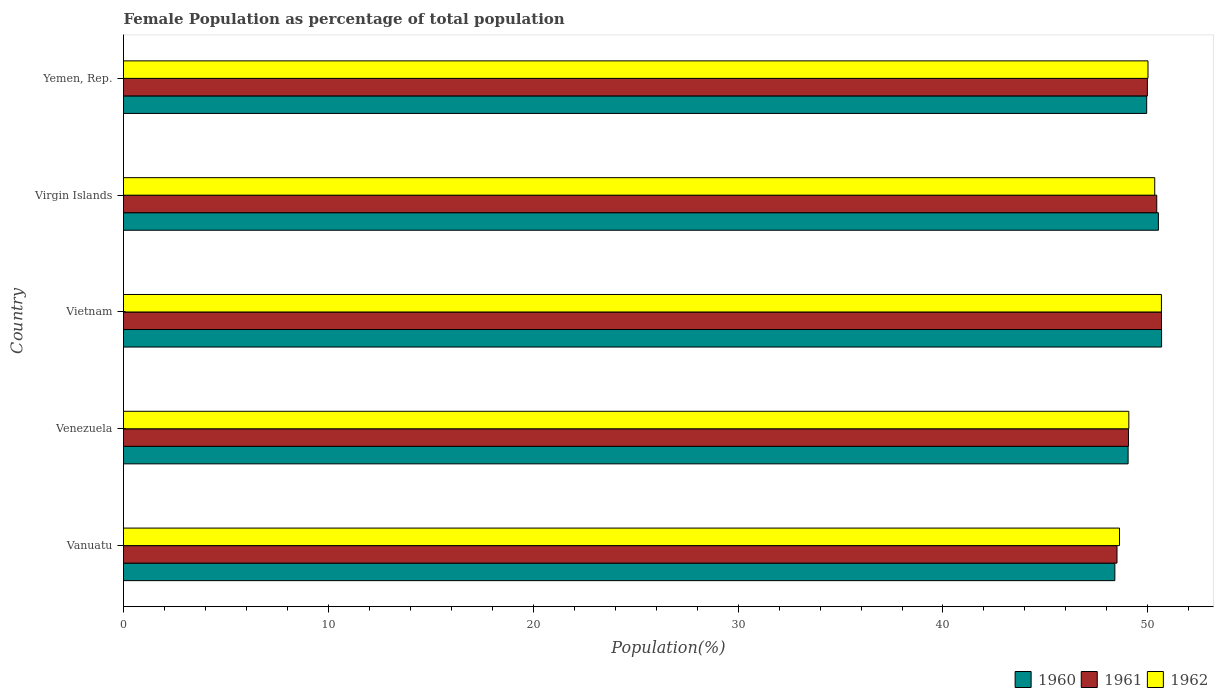Are the number of bars per tick equal to the number of legend labels?
Your response must be concise. Yes. Are the number of bars on each tick of the Y-axis equal?
Your answer should be very brief. Yes. How many bars are there on the 5th tick from the top?
Provide a succinct answer. 3. What is the label of the 2nd group of bars from the top?
Make the answer very short. Virgin Islands. What is the female population in in 1962 in Virgin Islands?
Your answer should be very brief. 50.34. Across all countries, what is the maximum female population in in 1961?
Your response must be concise. 50.67. Across all countries, what is the minimum female population in in 1962?
Your response must be concise. 48.62. In which country was the female population in in 1961 maximum?
Your answer should be compact. Vietnam. In which country was the female population in in 1960 minimum?
Provide a succinct answer. Vanuatu. What is the total female population in in 1962 in the graph?
Provide a short and direct response. 248.69. What is the difference between the female population in in 1960 in Vanuatu and that in Virgin Islands?
Provide a short and direct response. -2.12. What is the difference between the female population in in 1962 in Venezuela and the female population in in 1961 in Vanuatu?
Offer a terse response. 0.58. What is the average female population in in 1961 per country?
Provide a short and direct response. 49.73. What is the difference between the female population in in 1961 and female population in in 1962 in Virgin Islands?
Keep it short and to the point. 0.1. In how many countries, is the female population in in 1960 greater than 24 %?
Make the answer very short. 5. What is the ratio of the female population in in 1961 in Vanuatu to that in Vietnam?
Provide a short and direct response. 0.96. Is the difference between the female population in in 1961 in Vietnam and Yemen, Rep. greater than the difference between the female population in in 1962 in Vietnam and Yemen, Rep.?
Keep it short and to the point. Yes. What is the difference between the highest and the second highest female population in in 1960?
Your response must be concise. 0.16. What is the difference between the highest and the lowest female population in in 1960?
Your response must be concise. 2.28. What does the 3rd bar from the top in Yemen, Rep. represents?
Your answer should be compact. 1960. How many bars are there?
Your answer should be very brief. 15. How many countries are there in the graph?
Make the answer very short. 5. What is the difference between two consecutive major ticks on the X-axis?
Provide a short and direct response. 10. How are the legend labels stacked?
Make the answer very short. Horizontal. What is the title of the graph?
Your answer should be compact. Female Population as percentage of total population. Does "1964" appear as one of the legend labels in the graph?
Make the answer very short. No. What is the label or title of the X-axis?
Ensure brevity in your answer.  Population(%). What is the label or title of the Y-axis?
Make the answer very short. Country. What is the Population(%) in 1960 in Vanuatu?
Your answer should be very brief. 48.39. What is the Population(%) of 1961 in Vanuatu?
Keep it short and to the point. 48.49. What is the Population(%) in 1962 in Vanuatu?
Offer a very short reply. 48.62. What is the Population(%) in 1960 in Venezuela?
Offer a very short reply. 49.04. What is the Population(%) in 1961 in Venezuela?
Offer a very short reply. 49.05. What is the Population(%) in 1962 in Venezuela?
Give a very brief answer. 49.07. What is the Population(%) in 1960 in Vietnam?
Your response must be concise. 50.67. What is the Population(%) of 1961 in Vietnam?
Provide a short and direct response. 50.67. What is the Population(%) of 1962 in Vietnam?
Offer a terse response. 50.66. What is the Population(%) of 1960 in Virgin Islands?
Provide a succinct answer. 50.51. What is the Population(%) in 1961 in Virgin Islands?
Offer a terse response. 50.43. What is the Population(%) of 1962 in Virgin Islands?
Your answer should be very brief. 50.34. What is the Population(%) of 1960 in Yemen, Rep.?
Provide a succinct answer. 49.94. What is the Population(%) of 1961 in Yemen, Rep.?
Make the answer very short. 49.98. What is the Population(%) of 1962 in Yemen, Rep.?
Ensure brevity in your answer.  50.01. Across all countries, what is the maximum Population(%) of 1960?
Your response must be concise. 50.67. Across all countries, what is the maximum Population(%) of 1961?
Ensure brevity in your answer.  50.67. Across all countries, what is the maximum Population(%) in 1962?
Make the answer very short. 50.66. Across all countries, what is the minimum Population(%) of 1960?
Your answer should be very brief. 48.39. Across all countries, what is the minimum Population(%) in 1961?
Your response must be concise. 48.49. Across all countries, what is the minimum Population(%) in 1962?
Provide a succinct answer. 48.62. What is the total Population(%) of 1960 in the graph?
Keep it short and to the point. 248.56. What is the total Population(%) in 1961 in the graph?
Keep it short and to the point. 248.63. What is the total Population(%) in 1962 in the graph?
Provide a succinct answer. 248.69. What is the difference between the Population(%) of 1960 in Vanuatu and that in Venezuela?
Your response must be concise. -0.65. What is the difference between the Population(%) of 1961 in Vanuatu and that in Venezuela?
Provide a short and direct response. -0.56. What is the difference between the Population(%) of 1962 in Vanuatu and that in Venezuela?
Give a very brief answer. -0.46. What is the difference between the Population(%) of 1960 in Vanuatu and that in Vietnam?
Keep it short and to the point. -2.28. What is the difference between the Population(%) in 1961 in Vanuatu and that in Vietnam?
Give a very brief answer. -2.17. What is the difference between the Population(%) of 1962 in Vanuatu and that in Vietnam?
Offer a terse response. -2.05. What is the difference between the Population(%) of 1960 in Vanuatu and that in Virgin Islands?
Your answer should be very brief. -2.12. What is the difference between the Population(%) in 1961 in Vanuatu and that in Virgin Islands?
Your response must be concise. -1.94. What is the difference between the Population(%) of 1962 in Vanuatu and that in Virgin Islands?
Offer a terse response. -1.72. What is the difference between the Population(%) in 1960 in Vanuatu and that in Yemen, Rep.?
Make the answer very short. -1.55. What is the difference between the Population(%) in 1961 in Vanuatu and that in Yemen, Rep.?
Provide a succinct answer. -1.48. What is the difference between the Population(%) of 1962 in Vanuatu and that in Yemen, Rep.?
Offer a terse response. -1.39. What is the difference between the Population(%) of 1960 in Venezuela and that in Vietnam?
Make the answer very short. -1.63. What is the difference between the Population(%) in 1961 in Venezuela and that in Vietnam?
Provide a short and direct response. -1.61. What is the difference between the Population(%) in 1962 in Venezuela and that in Vietnam?
Your response must be concise. -1.59. What is the difference between the Population(%) in 1960 in Venezuela and that in Virgin Islands?
Your answer should be very brief. -1.48. What is the difference between the Population(%) of 1961 in Venezuela and that in Virgin Islands?
Offer a very short reply. -1.38. What is the difference between the Population(%) of 1962 in Venezuela and that in Virgin Islands?
Provide a succinct answer. -1.26. What is the difference between the Population(%) of 1960 in Venezuela and that in Yemen, Rep.?
Provide a succinct answer. -0.91. What is the difference between the Population(%) in 1961 in Venezuela and that in Yemen, Rep.?
Keep it short and to the point. -0.92. What is the difference between the Population(%) of 1962 in Venezuela and that in Yemen, Rep.?
Your answer should be compact. -0.94. What is the difference between the Population(%) of 1960 in Vietnam and that in Virgin Islands?
Offer a very short reply. 0.16. What is the difference between the Population(%) of 1961 in Vietnam and that in Virgin Islands?
Provide a succinct answer. 0.23. What is the difference between the Population(%) in 1962 in Vietnam and that in Virgin Islands?
Make the answer very short. 0.33. What is the difference between the Population(%) in 1960 in Vietnam and that in Yemen, Rep.?
Your answer should be very brief. 0.73. What is the difference between the Population(%) in 1961 in Vietnam and that in Yemen, Rep.?
Give a very brief answer. 0.69. What is the difference between the Population(%) of 1962 in Vietnam and that in Yemen, Rep.?
Ensure brevity in your answer.  0.66. What is the difference between the Population(%) of 1960 in Virgin Islands and that in Yemen, Rep.?
Your answer should be compact. 0.57. What is the difference between the Population(%) of 1961 in Virgin Islands and that in Yemen, Rep.?
Give a very brief answer. 0.46. What is the difference between the Population(%) of 1962 in Virgin Islands and that in Yemen, Rep.?
Make the answer very short. 0.33. What is the difference between the Population(%) of 1960 in Vanuatu and the Population(%) of 1961 in Venezuela?
Your answer should be very brief. -0.66. What is the difference between the Population(%) of 1960 in Vanuatu and the Population(%) of 1962 in Venezuela?
Provide a succinct answer. -0.68. What is the difference between the Population(%) of 1961 in Vanuatu and the Population(%) of 1962 in Venezuela?
Your response must be concise. -0.58. What is the difference between the Population(%) in 1960 in Vanuatu and the Population(%) in 1961 in Vietnam?
Give a very brief answer. -2.28. What is the difference between the Population(%) in 1960 in Vanuatu and the Population(%) in 1962 in Vietnam?
Offer a very short reply. -2.27. What is the difference between the Population(%) of 1961 in Vanuatu and the Population(%) of 1962 in Vietnam?
Offer a very short reply. -2.17. What is the difference between the Population(%) in 1960 in Vanuatu and the Population(%) in 1961 in Virgin Islands?
Give a very brief answer. -2.04. What is the difference between the Population(%) of 1960 in Vanuatu and the Population(%) of 1962 in Virgin Islands?
Provide a short and direct response. -1.95. What is the difference between the Population(%) of 1961 in Vanuatu and the Population(%) of 1962 in Virgin Islands?
Ensure brevity in your answer.  -1.84. What is the difference between the Population(%) of 1960 in Vanuatu and the Population(%) of 1961 in Yemen, Rep.?
Provide a succinct answer. -1.59. What is the difference between the Population(%) of 1960 in Vanuatu and the Population(%) of 1962 in Yemen, Rep.?
Your answer should be compact. -1.62. What is the difference between the Population(%) in 1961 in Vanuatu and the Population(%) in 1962 in Yemen, Rep.?
Your response must be concise. -1.51. What is the difference between the Population(%) in 1960 in Venezuela and the Population(%) in 1961 in Vietnam?
Ensure brevity in your answer.  -1.63. What is the difference between the Population(%) in 1960 in Venezuela and the Population(%) in 1962 in Vietnam?
Make the answer very short. -1.63. What is the difference between the Population(%) in 1961 in Venezuela and the Population(%) in 1962 in Vietnam?
Keep it short and to the point. -1.61. What is the difference between the Population(%) of 1960 in Venezuela and the Population(%) of 1961 in Virgin Islands?
Keep it short and to the point. -1.4. What is the difference between the Population(%) of 1960 in Venezuela and the Population(%) of 1962 in Virgin Islands?
Make the answer very short. -1.3. What is the difference between the Population(%) of 1961 in Venezuela and the Population(%) of 1962 in Virgin Islands?
Your answer should be compact. -1.28. What is the difference between the Population(%) of 1960 in Venezuela and the Population(%) of 1961 in Yemen, Rep.?
Your answer should be very brief. -0.94. What is the difference between the Population(%) of 1960 in Venezuela and the Population(%) of 1962 in Yemen, Rep.?
Provide a short and direct response. -0.97. What is the difference between the Population(%) in 1961 in Venezuela and the Population(%) in 1962 in Yemen, Rep.?
Your response must be concise. -0.95. What is the difference between the Population(%) in 1960 in Vietnam and the Population(%) in 1961 in Virgin Islands?
Keep it short and to the point. 0.24. What is the difference between the Population(%) of 1960 in Vietnam and the Population(%) of 1962 in Virgin Islands?
Give a very brief answer. 0.33. What is the difference between the Population(%) of 1961 in Vietnam and the Population(%) of 1962 in Virgin Islands?
Provide a succinct answer. 0.33. What is the difference between the Population(%) of 1960 in Vietnam and the Population(%) of 1961 in Yemen, Rep.?
Your response must be concise. 0.69. What is the difference between the Population(%) of 1960 in Vietnam and the Population(%) of 1962 in Yemen, Rep.?
Offer a very short reply. 0.66. What is the difference between the Population(%) of 1961 in Vietnam and the Population(%) of 1962 in Yemen, Rep.?
Provide a succinct answer. 0.66. What is the difference between the Population(%) of 1960 in Virgin Islands and the Population(%) of 1961 in Yemen, Rep.?
Give a very brief answer. 0.54. What is the difference between the Population(%) of 1960 in Virgin Islands and the Population(%) of 1962 in Yemen, Rep.?
Provide a succinct answer. 0.51. What is the difference between the Population(%) in 1961 in Virgin Islands and the Population(%) in 1962 in Yemen, Rep.?
Your response must be concise. 0.43. What is the average Population(%) in 1960 per country?
Your answer should be compact. 49.71. What is the average Population(%) of 1961 per country?
Ensure brevity in your answer.  49.73. What is the average Population(%) in 1962 per country?
Give a very brief answer. 49.74. What is the difference between the Population(%) of 1960 and Population(%) of 1961 in Vanuatu?
Your response must be concise. -0.1. What is the difference between the Population(%) of 1960 and Population(%) of 1962 in Vanuatu?
Your answer should be very brief. -0.23. What is the difference between the Population(%) of 1961 and Population(%) of 1962 in Vanuatu?
Offer a very short reply. -0.12. What is the difference between the Population(%) in 1960 and Population(%) in 1961 in Venezuela?
Your answer should be very brief. -0.02. What is the difference between the Population(%) in 1960 and Population(%) in 1962 in Venezuela?
Ensure brevity in your answer.  -0.04. What is the difference between the Population(%) of 1961 and Population(%) of 1962 in Venezuela?
Give a very brief answer. -0.02. What is the difference between the Population(%) in 1960 and Population(%) in 1961 in Vietnam?
Your answer should be very brief. 0. What is the difference between the Population(%) in 1960 and Population(%) in 1962 in Vietnam?
Offer a very short reply. 0.01. What is the difference between the Population(%) in 1961 and Population(%) in 1962 in Vietnam?
Provide a succinct answer. 0. What is the difference between the Population(%) of 1960 and Population(%) of 1961 in Virgin Islands?
Keep it short and to the point. 0.08. What is the difference between the Population(%) in 1960 and Population(%) in 1962 in Virgin Islands?
Make the answer very short. 0.18. What is the difference between the Population(%) of 1961 and Population(%) of 1962 in Virgin Islands?
Your answer should be compact. 0.1. What is the difference between the Population(%) in 1960 and Population(%) in 1961 in Yemen, Rep.?
Give a very brief answer. -0.03. What is the difference between the Population(%) in 1960 and Population(%) in 1962 in Yemen, Rep.?
Ensure brevity in your answer.  -0.06. What is the difference between the Population(%) in 1961 and Population(%) in 1962 in Yemen, Rep.?
Provide a succinct answer. -0.03. What is the ratio of the Population(%) in 1960 in Vanuatu to that in Venezuela?
Provide a short and direct response. 0.99. What is the ratio of the Population(%) in 1961 in Vanuatu to that in Venezuela?
Your answer should be very brief. 0.99. What is the ratio of the Population(%) in 1962 in Vanuatu to that in Venezuela?
Give a very brief answer. 0.99. What is the ratio of the Population(%) in 1960 in Vanuatu to that in Vietnam?
Your response must be concise. 0.95. What is the ratio of the Population(%) in 1961 in Vanuatu to that in Vietnam?
Provide a succinct answer. 0.96. What is the ratio of the Population(%) in 1962 in Vanuatu to that in Vietnam?
Your answer should be compact. 0.96. What is the ratio of the Population(%) of 1960 in Vanuatu to that in Virgin Islands?
Provide a succinct answer. 0.96. What is the ratio of the Population(%) of 1961 in Vanuatu to that in Virgin Islands?
Ensure brevity in your answer.  0.96. What is the ratio of the Population(%) in 1962 in Vanuatu to that in Virgin Islands?
Offer a very short reply. 0.97. What is the ratio of the Population(%) in 1960 in Vanuatu to that in Yemen, Rep.?
Your answer should be very brief. 0.97. What is the ratio of the Population(%) in 1961 in Vanuatu to that in Yemen, Rep.?
Keep it short and to the point. 0.97. What is the ratio of the Population(%) of 1962 in Vanuatu to that in Yemen, Rep.?
Offer a terse response. 0.97. What is the ratio of the Population(%) in 1960 in Venezuela to that in Vietnam?
Give a very brief answer. 0.97. What is the ratio of the Population(%) in 1961 in Venezuela to that in Vietnam?
Make the answer very short. 0.97. What is the ratio of the Population(%) in 1962 in Venezuela to that in Vietnam?
Keep it short and to the point. 0.97. What is the ratio of the Population(%) of 1960 in Venezuela to that in Virgin Islands?
Your response must be concise. 0.97. What is the ratio of the Population(%) of 1961 in Venezuela to that in Virgin Islands?
Offer a very short reply. 0.97. What is the ratio of the Population(%) in 1962 in Venezuela to that in Virgin Islands?
Make the answer very short. 0.97. What is the ratio of the Population(%) of 1960 in Venezuela to that in Yemen, Rep.?
Your response must be concise. 0.98. What is the ratio of the Population(%) in 1961 in Venezuela to that in Yemen, Rep.?
Offer a very short reply. 0.98. What is the ratio of the Population(%) of 1962 in Venezuela to that in Yemen, Rep.?
Offer a terse response. 0.98. What is the ratio of the Population(%) in 1961 in Vietnam to that in Virgin Islands?
Provide a succinct answer. 1. What is the ratio of the Population(%) of 1962 in Vietnam to that in Virgin Islands?
Ensure brevity in your answer.  1.01. What is the ratio of the Population(%) in 1960 in Vietnam to that in Yemen, Rep.?
Make the answer very short. 1.01. What is the ratio of the Population(%) of 1961 in Vietnam to that in Yemen, Rep.?
Give a very brief answer. 1.01. What is the ratio of the Population(%) of 1962 in Vietnam to that in Yemen, Rep.?
Provide a short and direct response. 1.01. What is the ratio of the Population(%) in 1960 in Virgin Islands to that in Yemen, Rep.?
Give a very brief answer. 1.01. What is the ratio of the Population(%) of 1961 in Virgin Islands to that in Yemen, Rep.?
Provide a short and direct response. 1.01. What is the ratio of the Population(%) of 1962 in Virgin Islands to that in Yemen, Rep.?
Offer a terse response. 1.01. What is the difference between the highest and the second highest Population(%) in 1960?
Provide a short and direct response. 0.16. What is the difference between the highest and the second highest Population(%) in 1961?
Your answer should be compact. 0.23. What is the difference between the highest and the second highest Population(%) of 1962?
Give a very brief answer. 0.33. What is the difference between the highest and the lowest Population(%) in 1960?
Ensure brevity in your answer.  2.28. What is the difference between the highest and the lowest Population(%) of 1961?
Offer a terse response. 2.17. What is the difference between the highest and the lowest Population(%) in 1962?
Your answer should be very brief. 2.05. 